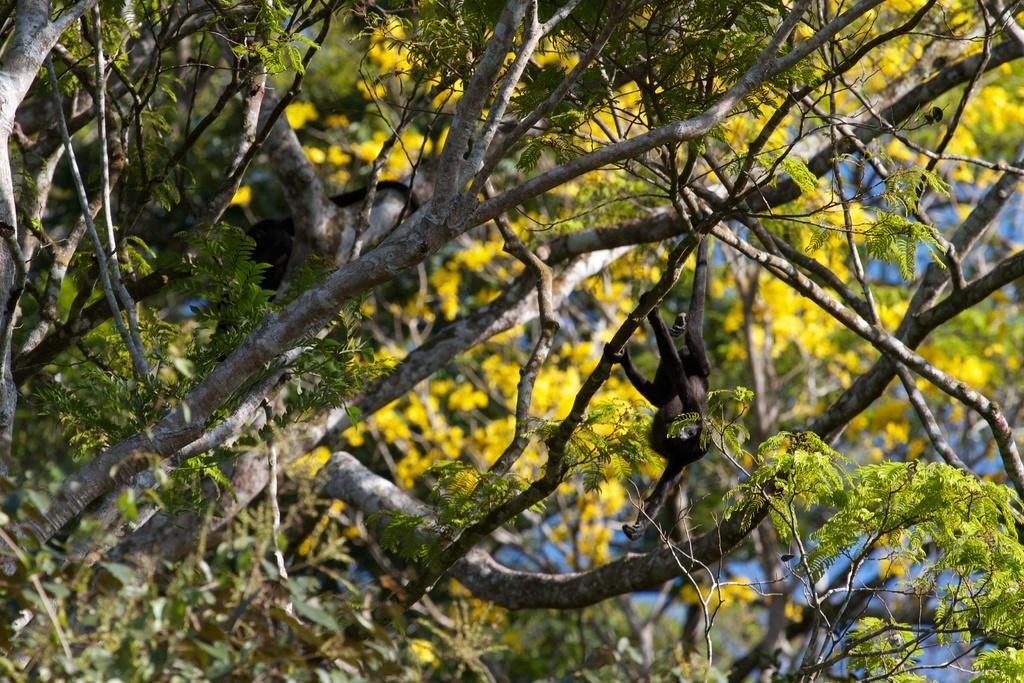In one or two sentences, can you explain what this image depicts? In this image there is a tree. 